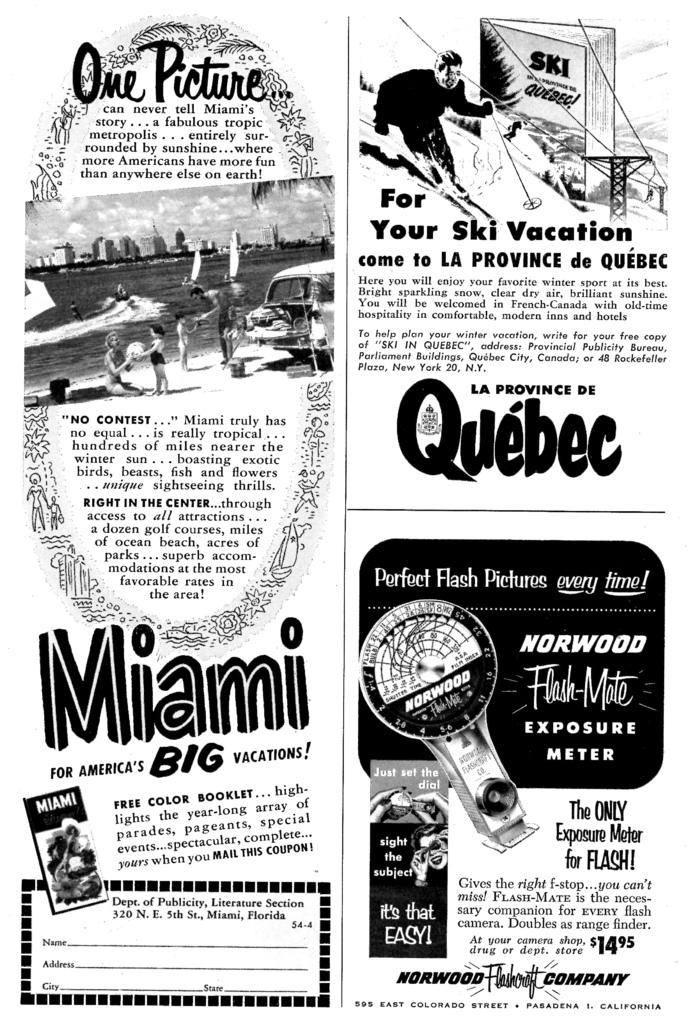What can be observed about the nature of the image? The image is edited. What else is present in the image besides the edited content? There is text and images of persons in the image. What is the weather like in the image? The provided facts do not mention anything about the weather, so it cannot be determined from the image. 